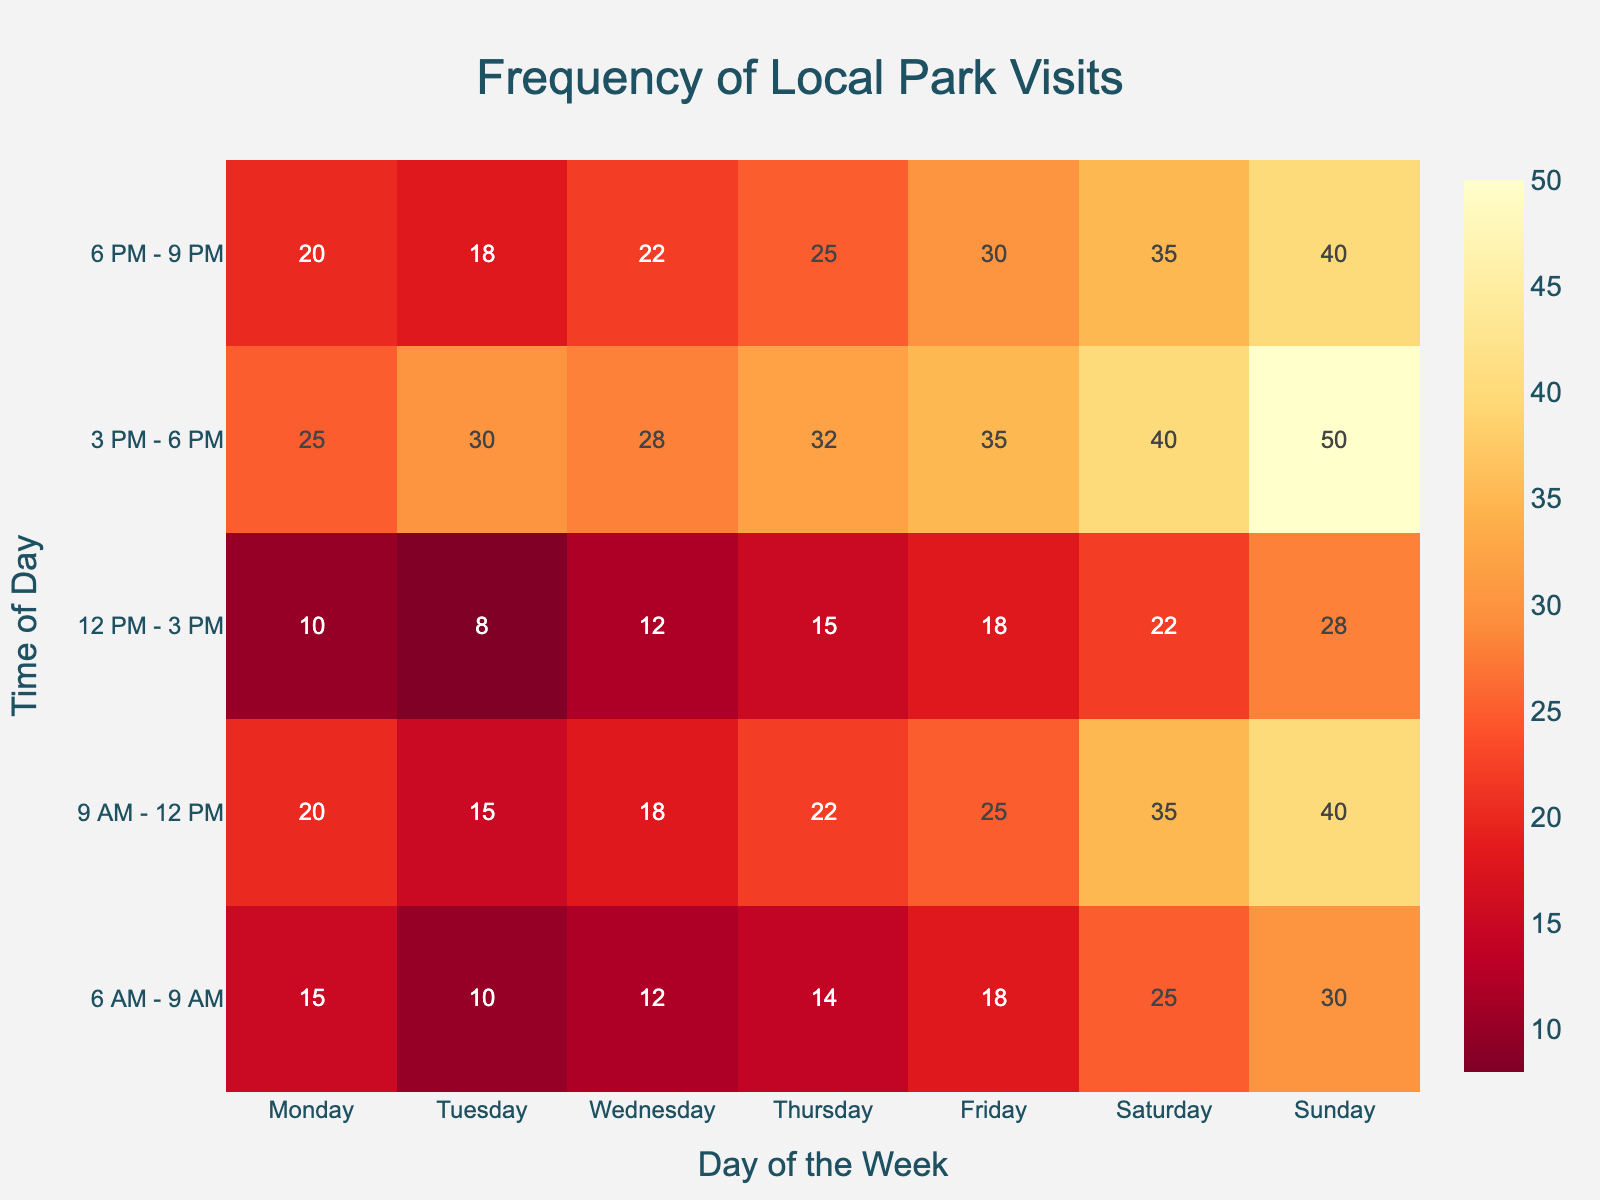what's the highest number of park visits recorded and on which day and time? The heatmap shows the frequency of visits, with different colors indicating different values. Look for the brightest (most intense) cell, which represents the highest value. The highest number is 50, recorded on Sunday from 3 PM - 6 PM.
Answer: 50 visits on Sunday from 3 PM - 6 PM what is the frequency of visits on Monday from 9 AM - 12 PM? Locate the column for Monday and find the row corresponding to 9 AM - 12 PM. The number in that cell is 20.
Answer: 20 When is the busiest time of day on average during weekdays (Monday to Friday)? Calculate the average number of visits for each time period during weekdays by summing the values for each time period from Monday to Friday and dividing by 5. For example, (15+10+12+14+18)/5 for 6 AM - 9 AM. Compare these averages to find the highest one.
Answer: 3 PM - 6 PM Which day has the least number of visits in the early morning (6 AM - 9 AM)? Look at the row for 6 AM - 9 AM and find the smallest number. The smallest value is 10, which occurs on Tuesday.
Answer: Tuesday How does the number of visits on Saturday from 12 PM - 3 PM compare to Friday from 12 PM - 3 PM? Locate the cell for Saturday from 12 PM - 3 PM (hovering line in the column Saturday, time 12 PM - 3 PM) and compare the value to the cell for Friday from 12 PM - 3 PM. Saturday has 22 visits and Friday has 18 visits, so Saturday is higher by 4.
Answer: Saturday is 4 visits higher Which time period is more popular on average, morning (6 AM - 9 AM) or evening (6 PM - 9 PM) across all days? Calculate the sum of visits for each time period across all days and find the average by dividing by 7. For mornings: (15+10+12+14+18+25+30)/7. For evenings: (20+18+22+25+30+35+40)/7. Compare these averages.
Answer: Evening What day has the highest visit count in the afternoon (12 PM - 3 PM)? Locate the row for 12 PM - 3 PM. Find the highest value in that row, which is 28 on Sunday.
Answer: Sunday How many total visits are recorded on Wednesday? Sum all frequency values in the Wednesday column: 12 + 18 + 12 + 28 + 22.
Answer: 92 Is Thursday busier than Wednesday overall? Sum the total visits for both Wednesday and Thursday columns. Wednesday has 92 (already calculated). For Thursday, sum the numbers: 14 + 22 + 15 + 32 + 25. Compare the sums.
Answer: Yes, Thursday is busier. (Total for Thursday is 108) Which day has the most consistent number of visits throughout the day? For each day, check the range of values (maximum value - minimum value). The day with the smallest range is the most consistent. For instance, compare the range of visits for each day.
Answer: Saturday (range is 35-22=13) 